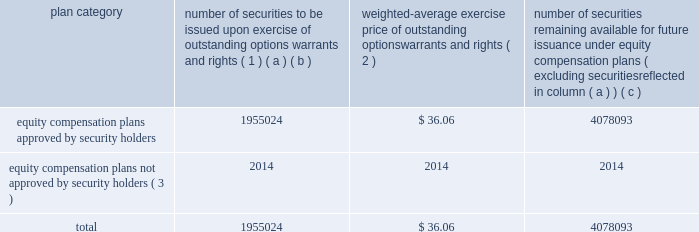Equity compensation plan information the table presents the equity securities available for issuance under our equity compensation plans as of december 31 , 2014 .
Equity compensation plan information plan category number of securities to be issued upon exercise of outstanding options , warrants and rights ( 1 ) weighted-average exercise price of outstanding options , warrants and rights ( 2 ) number of securities remaining available for future issuance under equity compensation plans ( excluding securities reflected in column ( a ) ) ( a ) ( b ) ( c ) equity compensation plans approved by security holders 1955024 $ 36.06 4078093 equity compensation plans not approved by security holders ( 3 ) 2014 2014 2014 .
( 1 ) includes grants made under the huntington ingalls industries , inc .
2012 long-term incentive stock plan ( the "2012 plan" ) , which was approved by our stockholders on may 2 , 2012 , and the huntington ingalls industries , inc .
2011 long-term incentive stock plan ( the "2011 plan" ) , which was approved by the sole stockholder of hii prior to its spin-off from northrop grumman corporation .
Of these shares , 644321 were subject to stock options , 539742 were subject to outstanding restricted performance stock rights , and 63022 were stock rights granted under the 2011 plan .
In addition , this number includes 33571 stock rights , 11046 restricted stock rights and 663322 restricted performance stock rights granted under the 2012 plan , assuming target performance achievement .
( 2 ) this is the weighted average exercise price of the 644321 outstanding stock options only .
( 3 ) there are no awards made under plans not approved by security holders .
Item 13 .
Certain relationships and related transactions , and director independence information as to certain relationships and related transactions and director independence will be incorporated herein by reference to the proxy statement for our 2015 annual meeting of stockholders to be filed within 120 days after the end of the company 2019s fiscal year .
Item 14 .
Principal accountant fees and services information as to principal accountant fees and services will be incorporated herein by reference to the proxy statement for our 2015 annual meeting of stockholders to be filed within 120 days after the end of the company 2019s fiscal year .
This proof is printed at 96% ( 96 % ) of original size this line represents final trim and will not print .
What portion of equity compensation plan remains available for future issuance? 
Computations: (4078093 / (1955024 + 4078093))
Answer: 0.67595. 